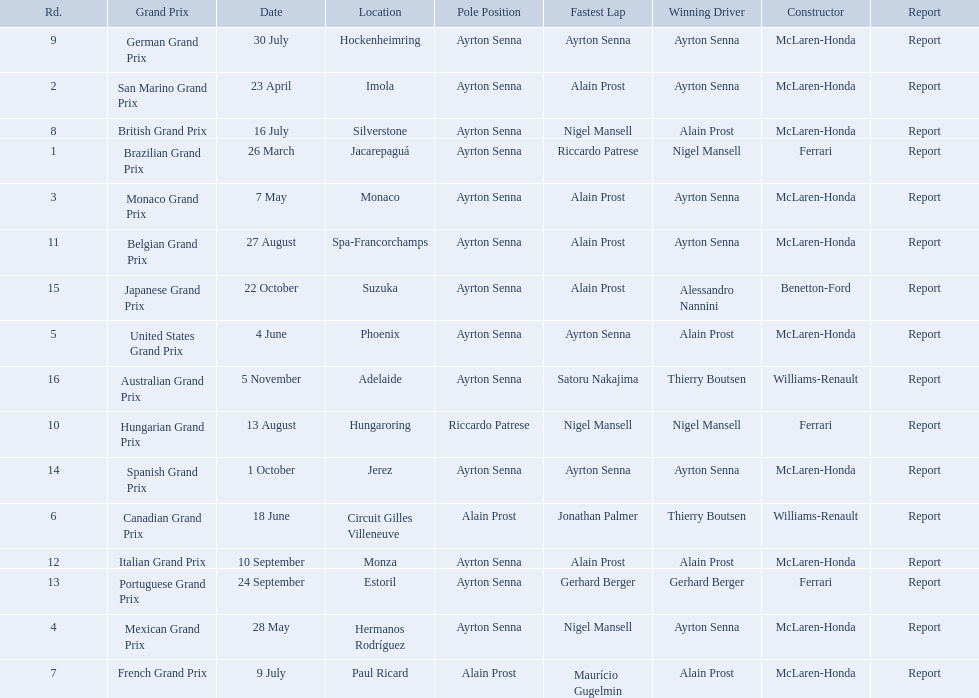What are all of the grand prix run in the 1989 formula one season? Brazilian Grand Prix, San Marino Grand Prix, Monaco Grand Prix, Mexican Grand Prix, United States Grand Prix, Canadian Grand Prix, French Grand Prix, British Grand Prix, German Grand Prix, Hungarian Grand Prix, Belgian Grand Prix, Italian Grand Prix, Portuguese Grand Prix, Spanish Grand Prix, Japanese Grand Prix, Australian Grand Prix. Of those 1989 formula one grand prix, which were run in october? Spanish Grand Prix, Japanese Grand Prix, Australian Grand Prix. Of those 1989 formula one grand prix run in october, which was the only one to be won by benetton-ford? Japanese Grand Prix. 